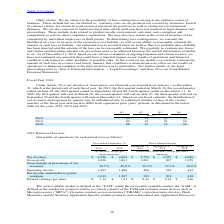According to Stmicroelectronics's financial document, In 2019, when did the first quarter ended? According to the financial document, March 30. The relevant text states: "fiscal year. In 2019, the first quarter ended on March 30, the second quarter ended on June 29, the third quarter ended on September 28 and the fourth quarte..." Also, In 2020, when did the first quarter ended? According to the financial document, March 28. The relevant text states: "cember 31. In 2020, the first quarter will end on March 28, the second quarter will end on June 27, the third quarter will end on September 26 and the fourth..." Also, What is the annual calendar of the financial cycle? from January 1 to December 31. The document states: "ticles of Association, our financial year extends from January 1 to December 31, which is the period end of each fiscal year. In 2019, the first quart..." Also, can you calculate: What are the average days in Q1? To answer this question, I need to perform calculations using the financial data. The calculation is: (90+89+88)/ 3, which equals 89. This is based on the information: "2020 88 91 91 96 2018 90 91 91 93 2019 89 91 91 94..." The key data points involved are: 88, 90. Also, can you calculate: What is the increase/ (decrease) in Q1 days from 2018 to 2020? Based on the calculation: 88-90, the result is -2. This is based on the information: "2020 88 91 91 96 2018 90 91 91 93..." The key data points involved are: 88, 90. Also, can you calculate: What is the increase/ (decrease) in Q4 days from 2018 to 2020? Based on the calculation: 96-93, the result is 3. This is based on the information: "2020 88 91 91 96 2018 90 91 91 93..." The key data points involved are: 93, 96. 